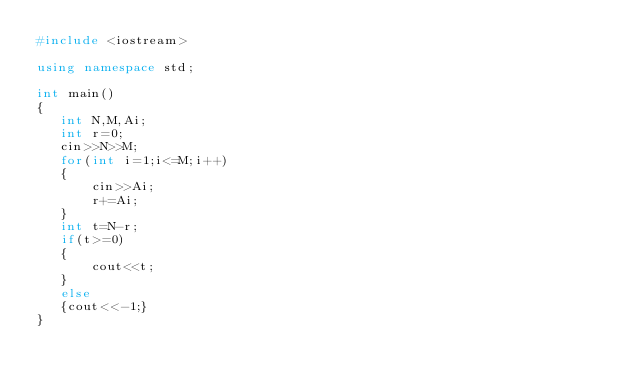<code> <loc_0><loc_0><loc_500><loc_500><_C++_>#include <iostream>

using namespace std;

int main()
{
   int N,M,Ai;
   int r=0;
   cin>>N>>M;
   for(int i=1;i<=M;i++)
   {
       cin>>Ai;
       r+=Ai;
   }
   int t=N-r;
   if(t>=0)
   {
       cout<<t;
   }
   else
   {cout<<-1;}
}
</code> 